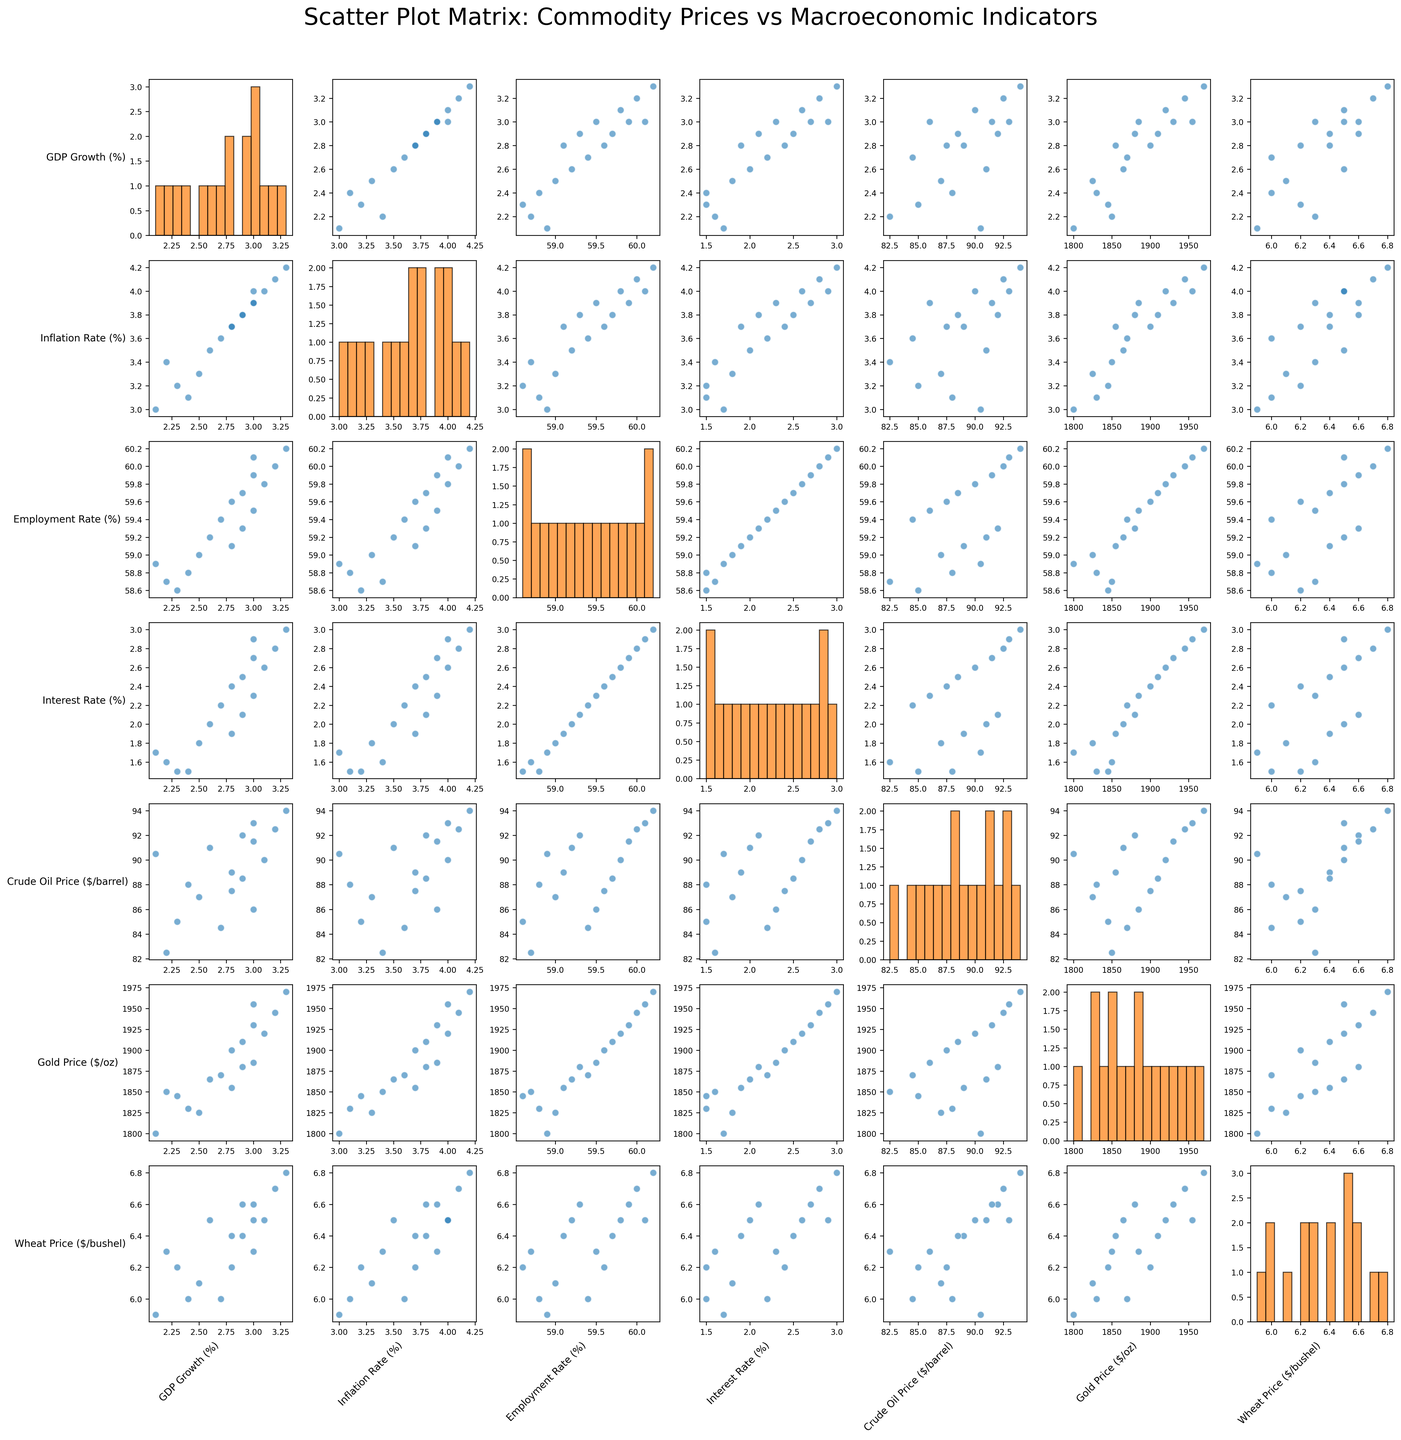How many variables are visually compared in the scatter plot matrix? The scatter plot matrix includes variables on both axes. Counting all unique variables used will give us the total number of variables compared. Here we have: 'GDP Growth (%)', 'Inflation Rate (%)', 'Employment Rate (%)', 'Interest Rate (%)', 'Crude Oil Price ($/barrel)', 'Gold Price ($/oz)', and 'Wheat Price ($/bushel)'.
Answer: 7 Which commodity price shows the highest overall correlation with the GDP Growth (%)? By looking at the scatter plots in the first row where GDP Growth (%) is compared with each of the other variables, we observe which scatter plot shows the strongest linear pattern. For instance, if the points for Crude Oil Price ($/barrel) are closely aligned along a line, it indicates a strong correlation.
Answer: Crude Oil Price ($/barrel) Which pair of variables seem to have the strongest positive correlation? In the scatter plot matrix, identify the scatter plot where points are closely aligned along a positive slope. For instance, a close inspection may reveal that 'Gold Price ($/oz)' vs 'Inflation Rate (%)' shows a strong positive alignment.
Answer: Gold Price ($/oz) and Inflation Rate (%) Does Employment Rate (%) appear to have a positive or negative correlation with Gold Price ($/oz)? Look at the specific scatter plot for 'Employment Rate (%)' vs 'Gold Price ($/oz)'. A positive correlation would show an upward trend, while a negative correlation would show a downward trend in the scatter points.
Answer: Positive What is the general trend between Interest Rate (%) and Crude Oil Price ($/barrel)? Locate the scatter plot for 'Interest Rate (%)' vs 'Crude Oil Price ($/barrel)'. Examine if there's a clear upward or downward trend in the distribution of points. If there are more points aligned upwards as Interest Rate (%) increases, there’s a positive correlation, and vice versa.
Answer: Positive Which variable shows the most spread in its histogram? Look at the diagonal plots, which show the histograms for each variable. Identify which variable’s histogram has the widest spread (largest range of values). For example, if 'Wheat Price ($/bushel)' has values ranging more widely than others, it will show the most spread.
Answer: Wheat Price ($/bushel) Which scatter plots suggest a potential outlier? Look through the scatter plots to find any plot where one or more points are far removed from the cluster of other points. For example, if most points cluster between certain ranges and one point is far off (e.g., [Inflation Rate vs Employment Rate]), it suggests a potential outlier.
Answer: Inflation Rate vs Employment Rate Is there any visible trend between the Inflation Rate and Employment Rate? Examine the scatter plot comparing 'Inflation Rate (%)' and 'Employment Rate (%)'. Check if an upward or downward trend in points can be observed.
Answer: Positive Does the plot suggest whether the Gold Price ($/oz) correlates more strongly with Interest Rate (%) or with Inflation Rate (%)? Compare the scatter plots of 'Gold Price ($/oz)' vs 'Interest Rate (%)' and 'Gold Price ($/oz)' vs 'Inflation Rate (%)'. Determine which plot shows points more aligned along a line, indicating a stronger correlation.
Answer: Inflation Rate (%) What trend can you observe between Wheat Price ($/bushel) and Crude Oil Price ($/barrel)? Look at the scatter plot between 'Wheat Price ($/bushel)' and 'Crude Oil Price ($/barrel)'. Identify if there is a substantive upward or downward trend in points, which indicates a correlation pattern.
Answer: Positive 